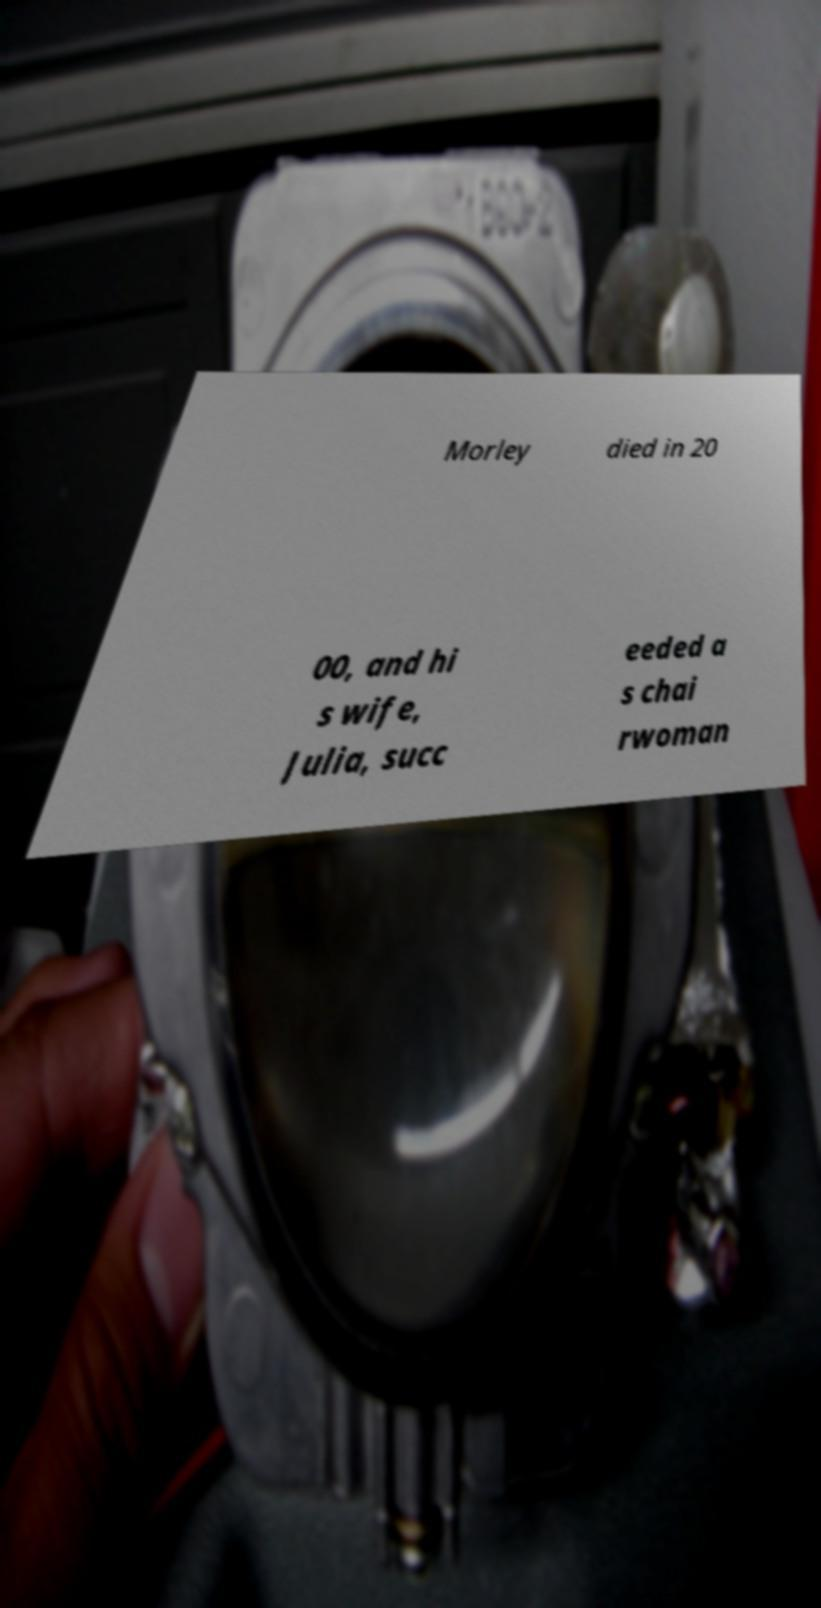Could you extract and type out the text from this image? Morley died in 20 00, and hi s wife, Julia, succ eeded a s chai rwoman 